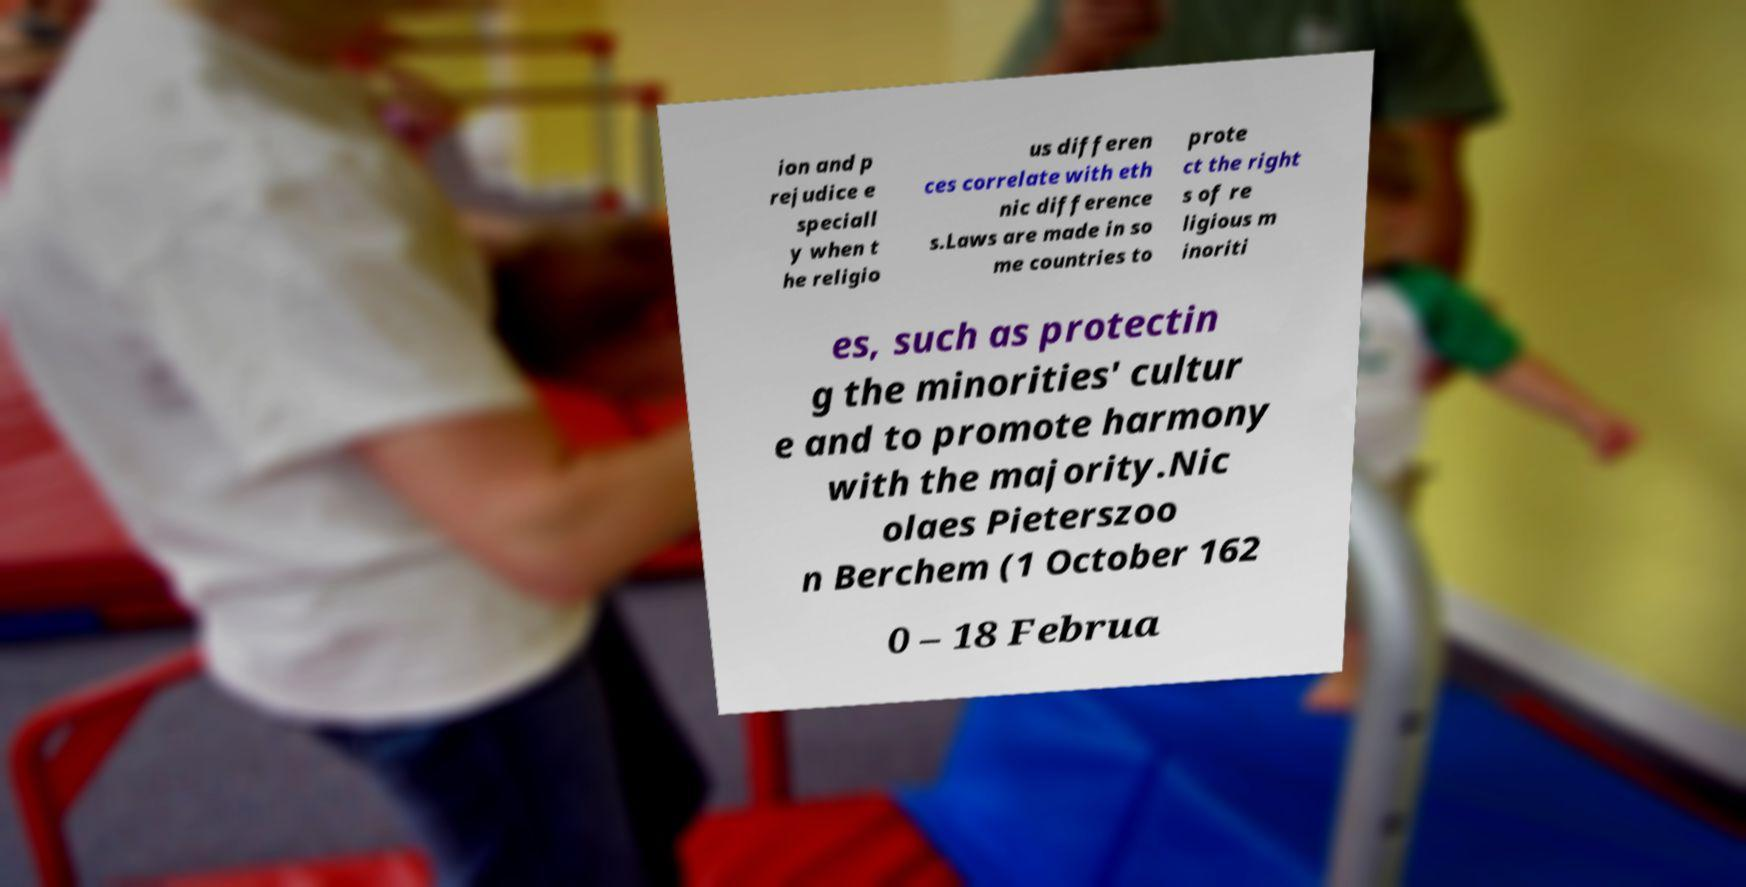What messages or text are displayed in this image? I need them in a readable, typed format. ion and p rejudice e speciall y when t he religio us differen ces correlate with eth nic difference s.Laws are made in so me countries to prote ct the right s of re ligious m inoriti es, such as protectin g the minorities' cultur e and to promote harmony with the majority.Nic olaes Pieterszoo n Berchem (1 October 162 0 – 18 Februa 